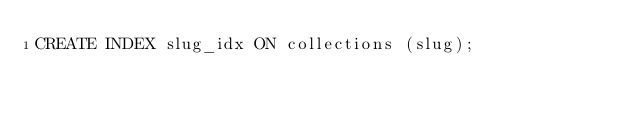<code> <loc_0><loc_0><loc_500><loc_500><_SQL_>CREATE INDEX slug_idx ON collections (slug);
</code> 